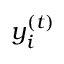Convert formula to latex. <formula><loc_0><loc_0><loc_500><loc_500>y _ { i } ^ { ( t ) }</formula> 